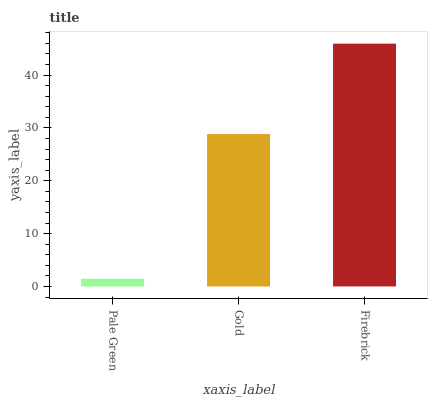Is Pale Green the minimum?
Answer yes or no. Yes. Is Firebrick the maximum?
Answer yes or no. Yes. Is Gold the minimum?
Answer yes or no. No. Is Gold the maximum?
Answer yes or no. No. Is Gold greater than Pale Green?
Answer yes or no. Yes. Is Pale Green less than Gold?
Answer yes or no. Yes. Is Pale Green greater than Gold?
Answer yes or no. No. Is Gold less than Pale Green?
Answer yes or no. No. Is Gold the high median?
Answer yes or no. Yes. Is Gold the low median?
Answer yes or no. Yes. Is Firebrick the high median?
Answer yes or no. No. Is Firebrick the low median?
Answer yes or no. No. 